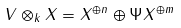<formula> <loc_0><loc_0><loc_500><loc_500>V \otimes _ { k } X = X ^ { \oplus n } \oplus \Psi X ^ { \oplus m }</formula> 